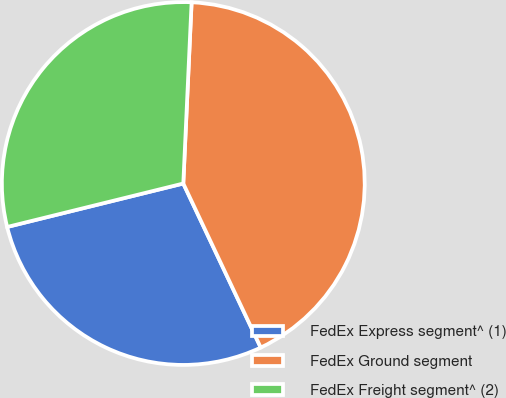Convert chart. <chart><loc_0><loc_0><loc_500><loc_500><pie_chart><fcel>FedEx Express segment^ (1)<fcel>FedEx Ground segment<fcel>FedEx Freight segment^ (2)<nl><fcel>28.17%<fcel>42.25%<fcel>29.58%<nl></chart> 